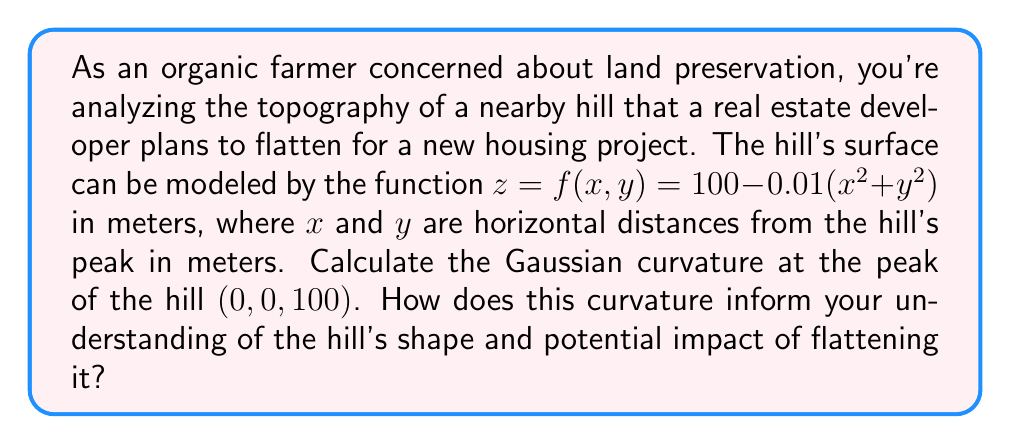What is the answer to this math problem? To analyze the curvature of the hill, we'll use differential geometry techniques to calculate the Gaussian curvature at the peak.

1) First, we need to calculate the partial derivatives:
   $f_x = -0.02x$
   $f_y = -0.02y$
   $f_{xx} = -0.02$
   $f_{yy} = -0.02$
   $f_{xy} = f_{yx} = 0$

2) At the peak (0, 0, 100), these simplify to:
   $f_x = f_y = 0$
   $f_{xx} = f_{yy} = -0.02$
   $f_{xy} = 0$

3) The Gaussian curvature K is given by:
   $$K = \frac{f_{xx}f_{yy} - f_{xy}^2}{(1 + f_x^2 + f_y^2)^2}$$

4) Substituting our values:
   $$K = \frac{(-0.02)(-0.02) - 0^2}{(1 + 0^2 + 0^2)^2} = \frac{0.0004}{1} = 0.0004$$

5) The positive Gaussian curvature indicates that the peak is a local maximum, resembling the top of a hill or mountain.

6) This curvature value, while positive, is relatively small. It suggests a gently rounded peak rather than a sharp one.

7) From an organic farmer's perspective, this gentle curvature implies:
   a) The hill likely has a stable soil structure, important for preventing erosion.
   b) The gradual slope could be suitable for certain types of agriculture or natural habitats.
   c) Flattening this hill would significantly alter the local ecosystem and potentially affect water drainage patterns.

Understanding this curvature helps quantify the natural contour of the land, providing a scientific basis for arguments against unnecessary land alteration.
Answer: The Gaussian curvature at the peak of the hill is 0.0004 m^(-2). This positive but small value indicates a gently rounded peak, suggesting a stable landform that plays a crucial role in the local ecosystem and hydrology. Flattening such a feature could have significant environmental impacts. 